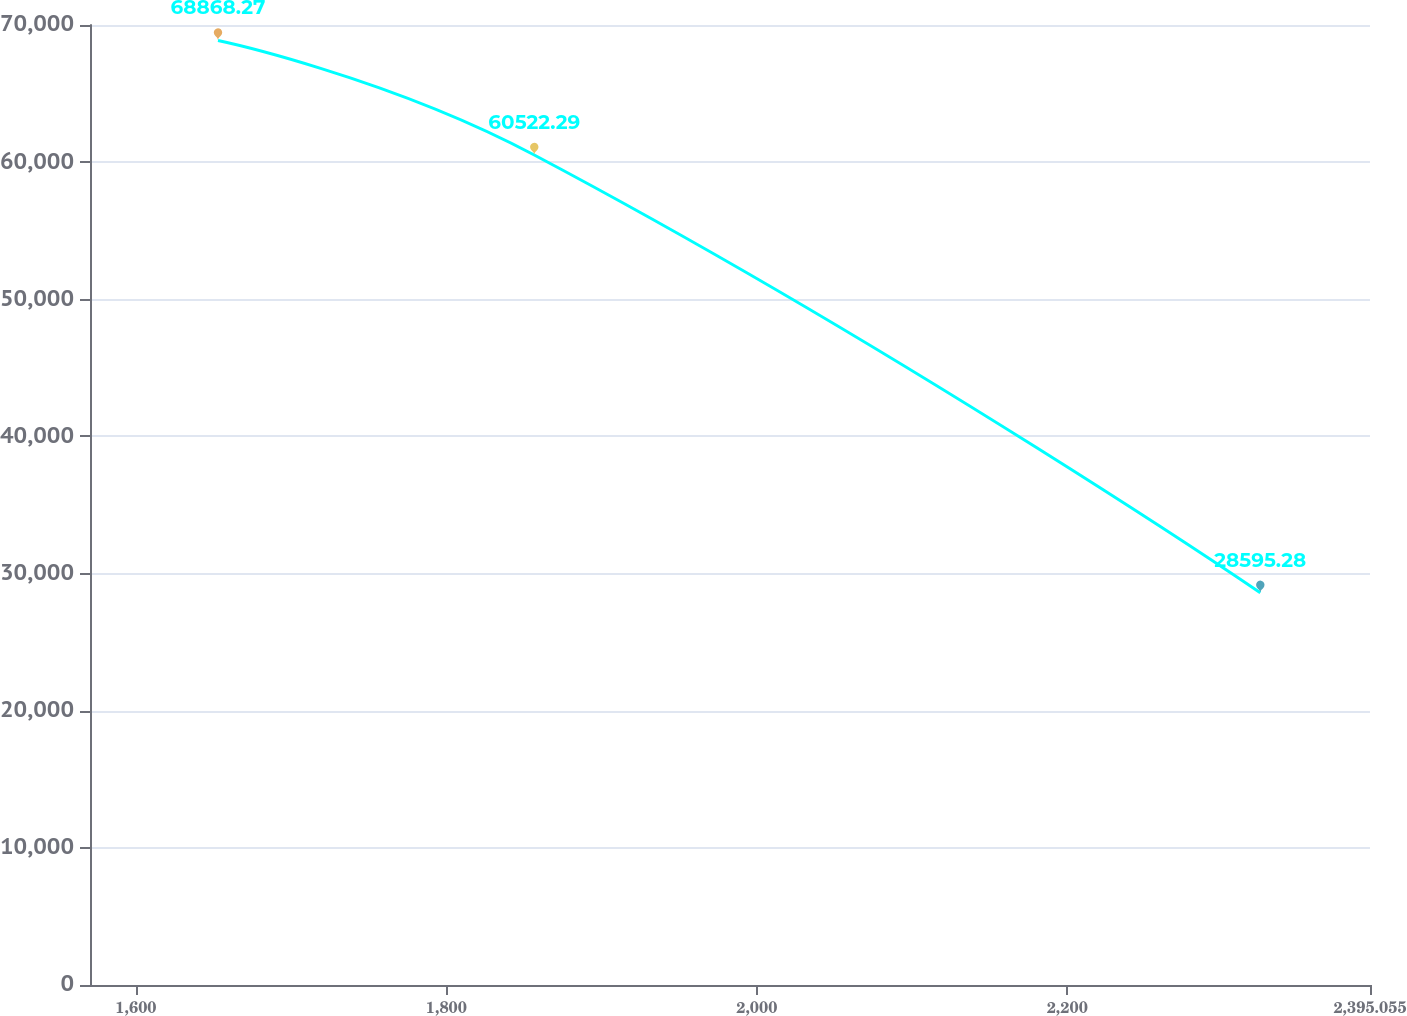Convert chart to OTSL. <chart><loc_0><loc_0><loc_500><loc_500><line_chart><ecel><fcel>Unnamed: 1<nl><fcel>1652.87<fcel>68868.3<nl><fcel>1856.64<fcel>60522.3<nl><fcel>2324.38<fcel>28595.3<nl><fcel>2400.95<fcel>93951.6<nl><fcel>2477.52<fcel>35130.9<nl></chart> 